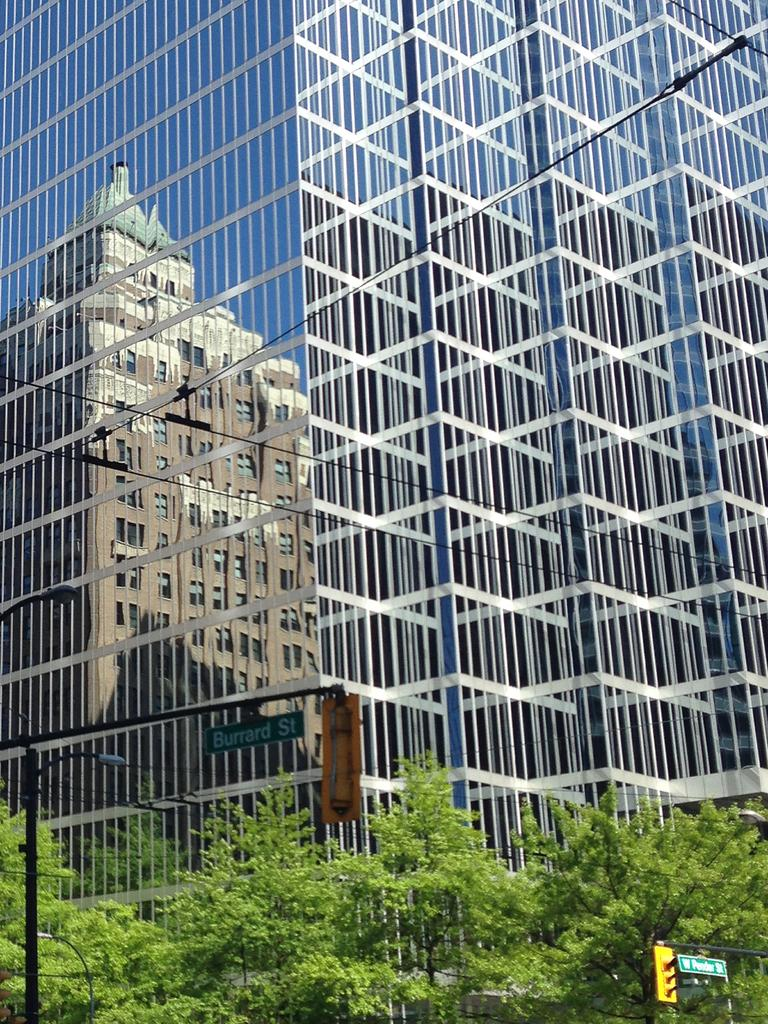What type of structure is present in the image? There is a building in the image. Can you describe any additional features related to the building? The reflection of a building is visible on the glass on the left side. What type of vegetation can be seen at the bottom of the image? There are trees at the bottom of the image. Are there any other objects or structures visible at the bottom of the image? Yes, there are poles at the bottom of the image. Is there a star visible in the image? There is no star present in the image. Is there a spy visible in the image? There is no person, let alone a spy, visible in the image. 